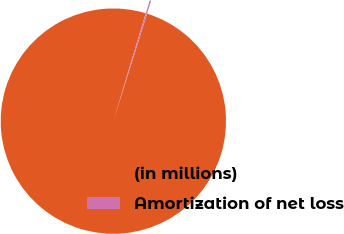Convert chart to OTSL. <chart><loc_0><loc_0><loc_500><loc_500><pie_chart><fcel>(in millions)<fcel>Amortization of net loss<nl><fcel>99.8%<fcel>0.2%<nl></chart> 